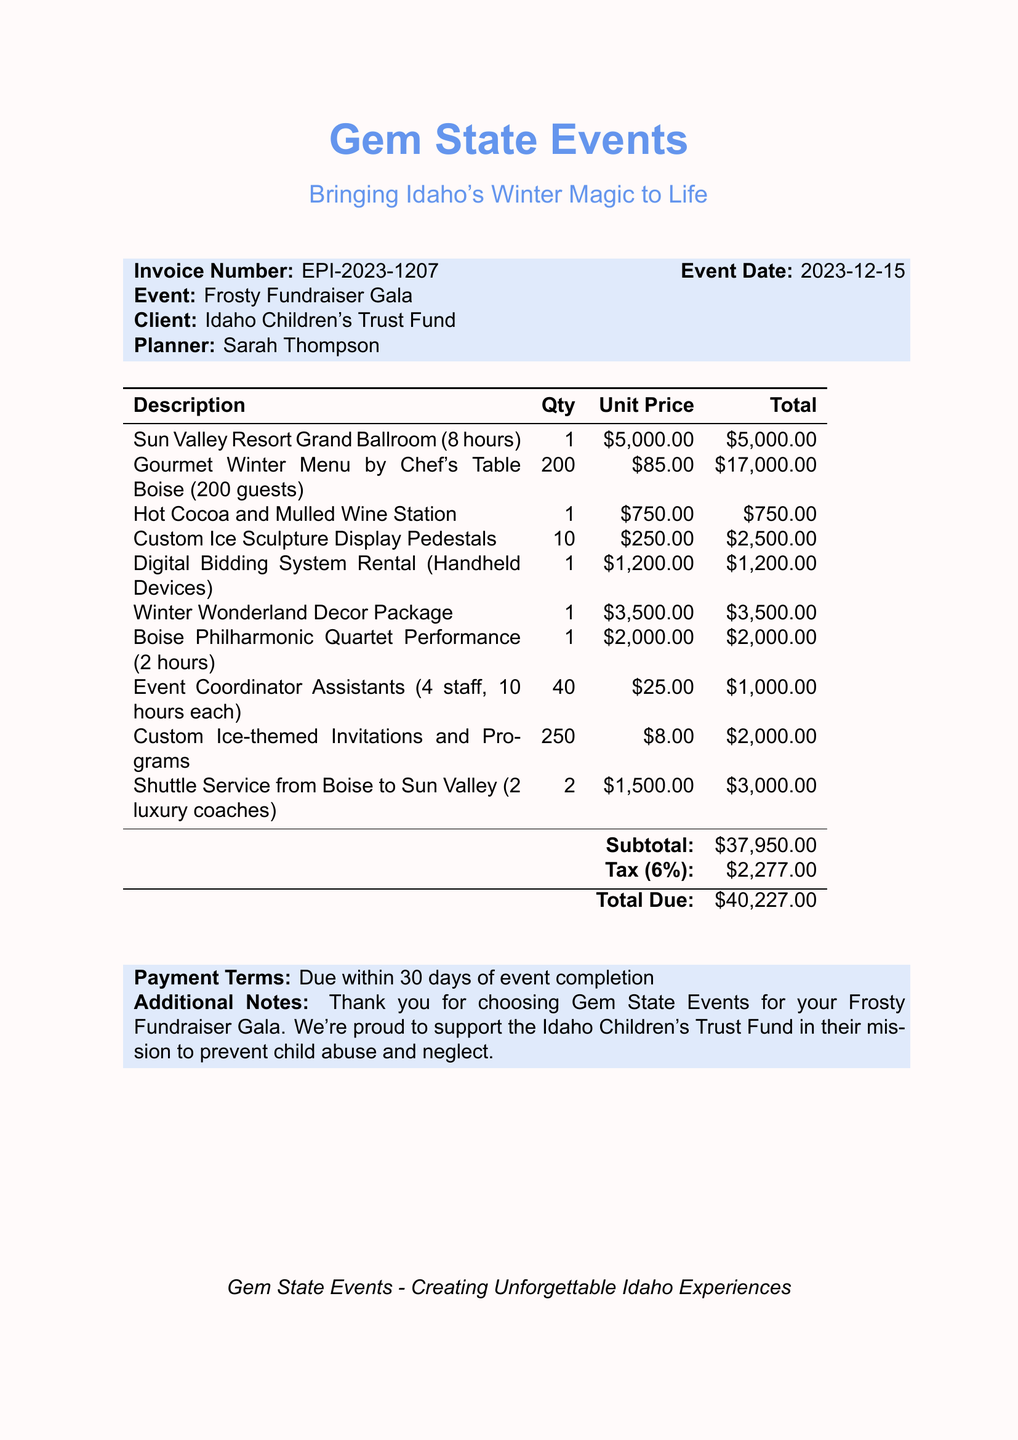What is the invoice number? The invoice number is listed prominently in the document for reference.
Answer: EPI-2023-1207 What is the event date? The event date is specified in the document, indicating when the gala will take place.
Answer: 2023-12-15 Who is the client? The client's name is mentioned, representing the organization hosting the event.
Answer: Idaho Children's Trust Fund How many guests is the catering plan for? The quantity of guests for the catering service is detailed in the item description.
Answer: 200 What is the total cost for the venue rental? The total cost for the venue is included in the itemized charges for clarity.
Answer: 5000 What is the total amount due? The document summarizes the total amount that needs to be paid after taxes.
Answer: 40227 What is the tax rate applied? The tax rate is specifically stated in the document to clarify the additional cost.
Answer: 6% How many custom ice sculpture display pedestals were ordered? The quantity of ice sculpture pedestals is specified in the silent auction setup item.
Answer: 10 What are the payment terms? The payment terms outline when the payment is required and are standard for invoices.
Answer: Due within 30 days of event completion 